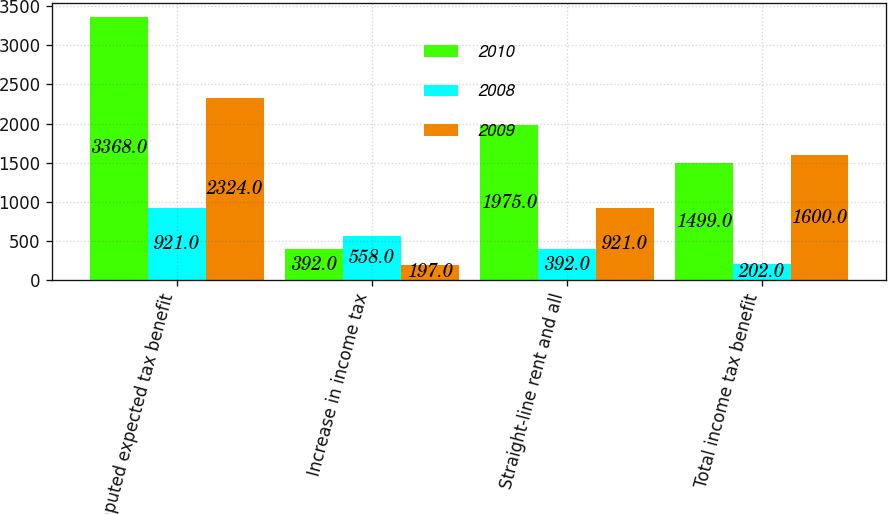<chart> <loc_0><loc_0><loc_500><loc_500><stacked_bar_chart><ecel><fcel>Computed expected tax benefit<fcel>Increase in income tax<fcel>Straight-line rent and all<fcel>Total income tax benefit<nl><fcel>2010<fcel>3368<fcel>392<fcel>1975<fcel>1499<nl><fcel>2008<fcel>921<fcel>558<fcel>392<fcel>202<nl><fcel>2009<fcel>2324<fcel>197<fcel>921<fcel>1600<nl></chart> 